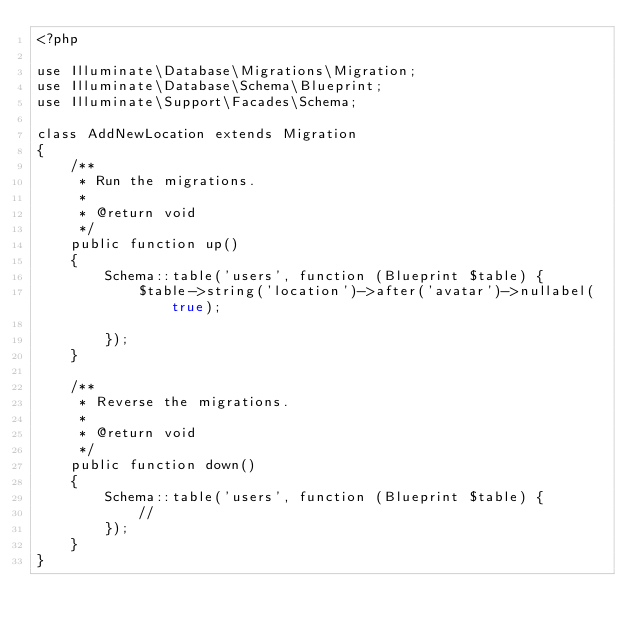Convert code to text. <code><loc_0><loc_0><loc_500><loc_500><_PHP_><?php

use Illuminate\Database\Migrations\Migration;
use Illuminate\Database\Schema\Blueprint;
use Illuminate\Support\Facades\Schema;

class AddNewLocation extends Migration
{
    /**
     * Run the migrations.
     *
     * @return void
     */
    public function up()
    {
        Schema::table('users', function (Blueprint $table) {
            $table->string('location')->after('avatar')->nullabel(true);

        });
    }

    /**
     * Reverse the migrations.
     *
     * @return void
     */
    public function down()
    {
        Schema::table('users', function (Blueprint $table) {
            //
        });
    }
}
</code> 